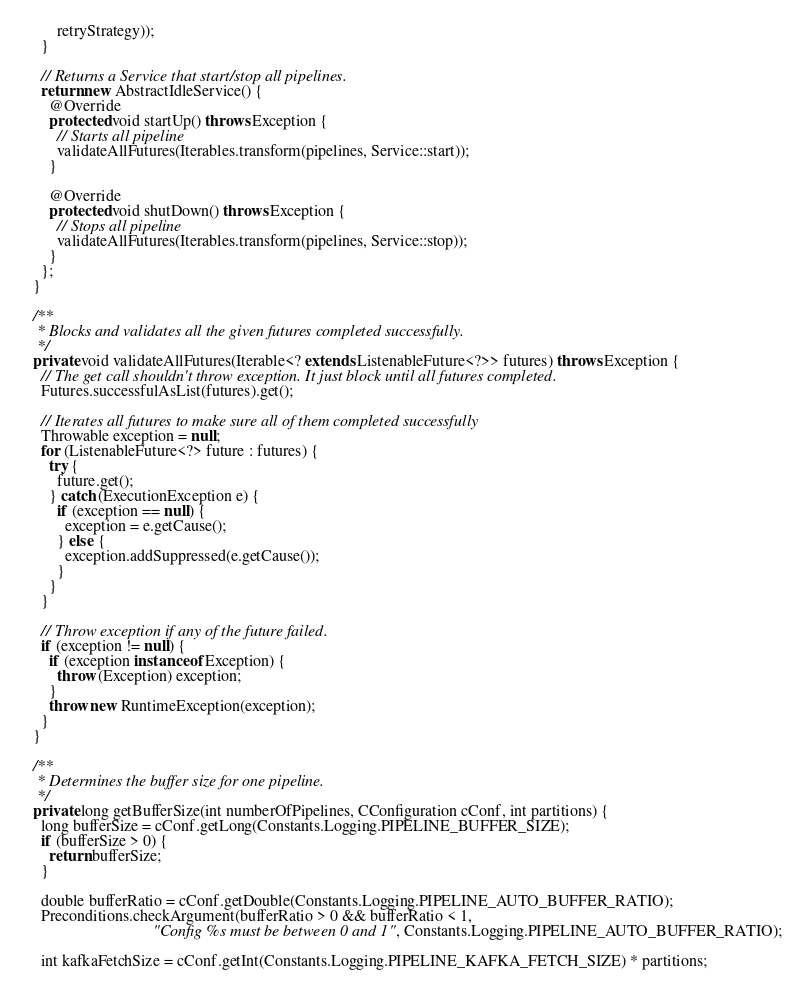Convert code to text. <code><loc_0><loc_0><loc_500><loc_500><_Java_>        retryStrategy));
    }

    // Returns a Service that start/stop all pipelines.
    return new AbstractIdleService() {
      @Override
      protected void startUp() throws Exception {
        // Starts all pipeline
        validateAllFutures(Iterables.transform(pipelines, Service::start));
      }

      @Override
      protected void shutDown() throws Exception {
        // Stops all pipeline
        validateAllFutures(Iterables.transform(pipelines, Service::stop));
      }
    };
  }

  /**
   * Blocks and validates all the given futures completed successfully.
   */
  private void validateAllFutures(Iterable<? extends ListenableFuture<?>> futures) throws Exception {
    // The get call shouldn't throw exception. It just block until all futures completed.
    Futures.successfulAsList(futures).get();

    // Iterates all futures to make sure all of them completed successfully
    Throwable exception = null;
    for (ListenableFuture<?> future : futures) {
      try {
        future.get();
      } catch (ExecutionException e) {
        if (exception == null) {
          exception = e.getCause();
        } else {
          exception.addSuppressed(e.getCause());
        }
      }
    }

    // Throw exception if any of the future failed.
    if (exception != null) {
      if (exception instanceof Exception) {
        throw (Exception) exception;
      }
      throw new RuntimeException(exception);
    }
  }

  /**
   * Determines the buffer size for one pipeline.
   */
  private long getBufferSize(int numberOfPipelines, CConfiguration cConf, int partitions) {
    long bufferSize = cConf.getLong(Constants.Logging.PIPELINE_BUFFER_SIZE);
    if (bufferSize > 0) {
      return bufferSize;
    }

    double bufferRatio = cConf.getDouble(Constants.Logging.PIPELINE_AUTO_BUFFER_RATIO);
    Preconditions.checkArgument(bufferRatio > 0 && bufferRatio < 1,
                                "Config %s must be between 0 and 1", Constants.Logging.PIPELINE_AUTO_BUFFER_RATIO);

    int kafkaFetchSize = cConf.getInt(Constants.Logging.PIPELINE_KAFKA_FETCH_SIZE) * partitions;
</code> 